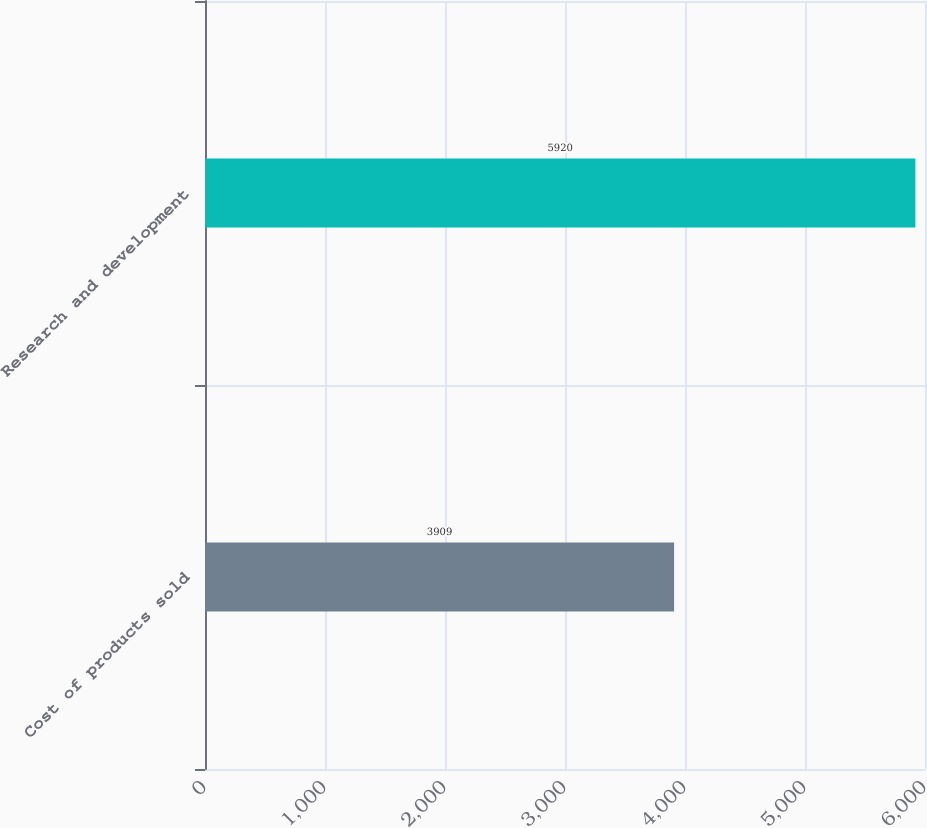Convert chart. <chart><loc_0><loc_0><loc_500><loc_500><bar_chart><fcel>Cost of products sold<fcel>Research and development<nl><fcel>3909<fcel>5920<nl></chart> 